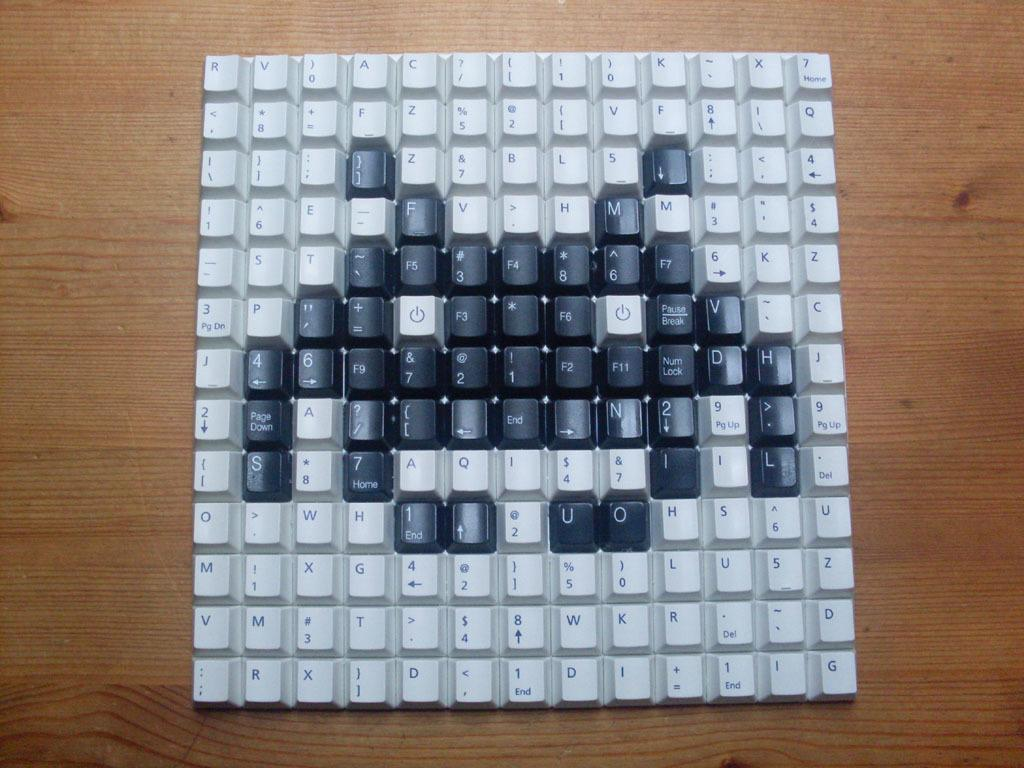Provide a one-sentence caption for the provided image. black ans white keys have been removed from a keyboard and the black ones have been used to make an alien, including U and O in the bottom right. 